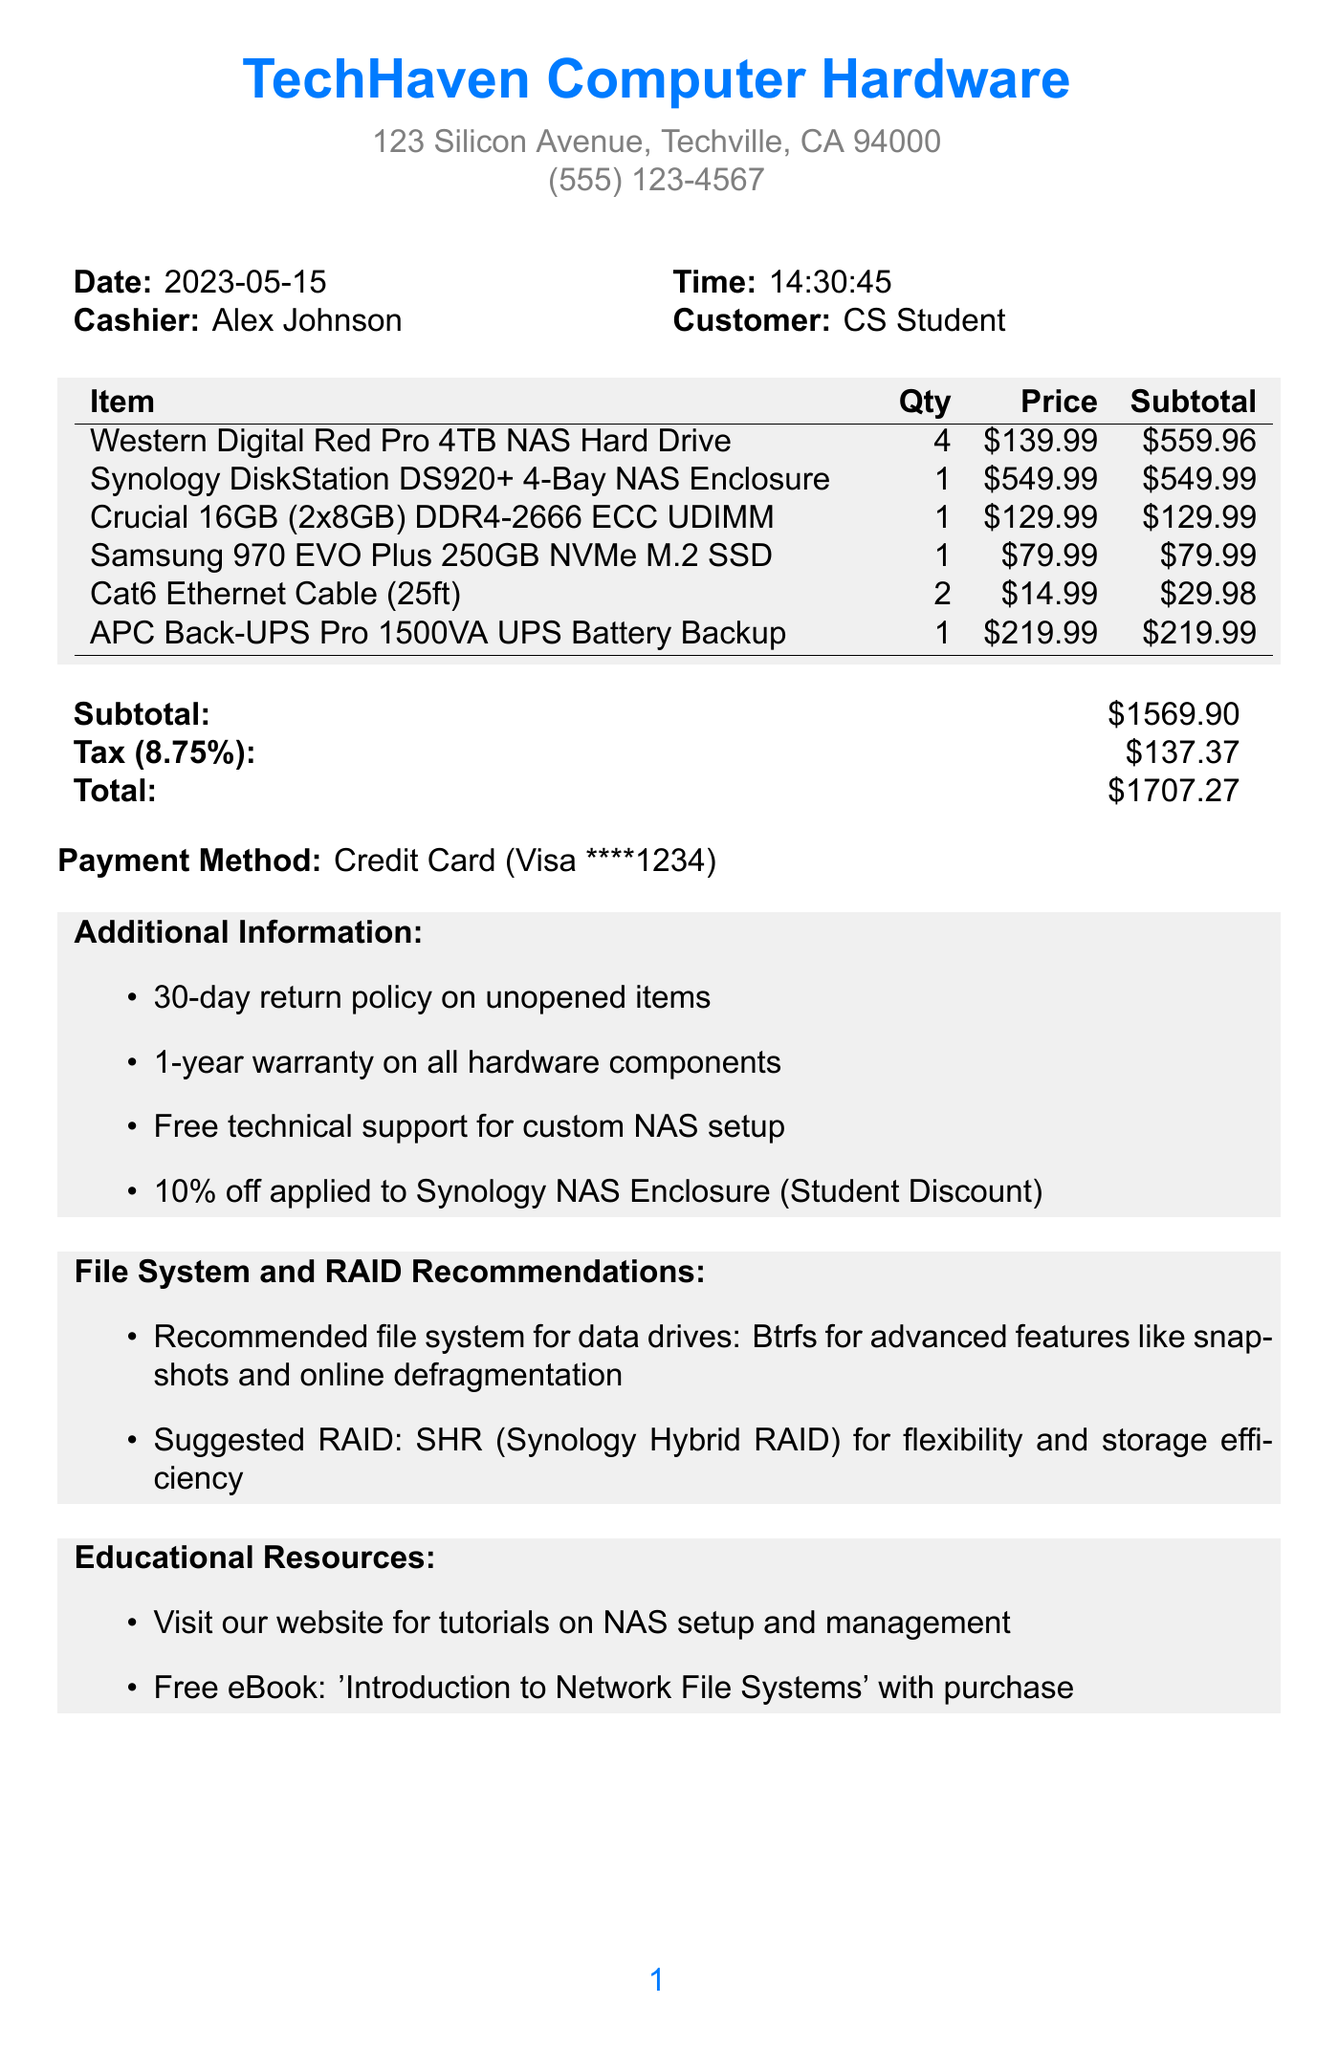what is the store name? The store name is prominently displayed at the top of the receipt as the business name.
Answer: TechHaven Computer Hardware who was the cashier? The cashier's name is listed next to the corresponding label on the receipt.
Answer: Alex Johnson what is the date of the transaction? The date of the transaction is clearly stated in the top section of the receipt.
Answer: 2023-05-15 how many Western Digital Red Pro hard drives were purchased? The number of hard drives purchased is mentioned in the itemized list.
Answer: 4 what is the total amount after tax? The total amount is calculated as the subtotal plus tax and presented at the bottom of the receipt.
Answer: 1707.27 what discount was applied to the Synology NAS Enclosure? The discount is noted as a percentage off next to the corresponding item on the receipt.
Answer: 10% off what file system is recommended for the data drives? The recommended file system for the data drives is specified in a dedicated section of the receipt.
Answer: Btrfs what is the suggested RAID configuration? The suggested RAID configuration is provided in the recommendations section as advice for customers.
Answer: SHR (Synology Hybrid RAID) how long is the warranty on Hardware components? The warranty period for hardware components is explicitly mentioned in the additional information section.
Answer: 1-year warranty 